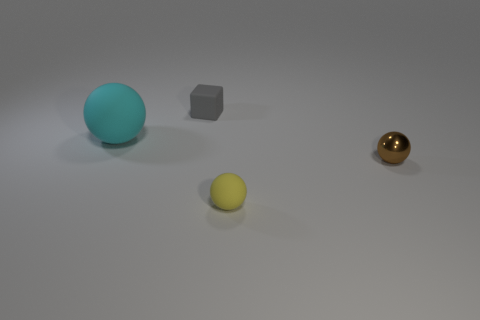There is a small matte object that is to the right of the tiny gray block; is its shape the same as the large cyan object?
Offer a very short reply. Yes. There is a rubber sphere that is on the left side of the tiny yellow rubber object; what is its color?
Make the answer very short. Cyan. What number of cubes are brown shiny objects or yellow matte things?
Offer a very short reply. 0. There is a rubber sphere behind the small yellow ball in front of the small brown sphere; what size is it?
Provide a succinct answer. Large. There is a metal thing; is it the same color as the sphere on the left side of the rubber block?
Give a very brief answer. No. How many spheres are in front of the rubber cube?
Offer a very short reply. 3. Are there fewer purple shiny things than gray matte things?
Ensure brevity in your answer.  Yes. There is a object that is both left of the brown object and right of the small matte cube; what is its size?
Give a very brief answer. Small. There is a rubber sphere to the right of the gray object; is its color the same as the tiny block?
Make the answer very short. No. Is the number of cyan objects to the right of the brown ball less than the number of small red rubber spheres?
Your answer should be very brief. No. 